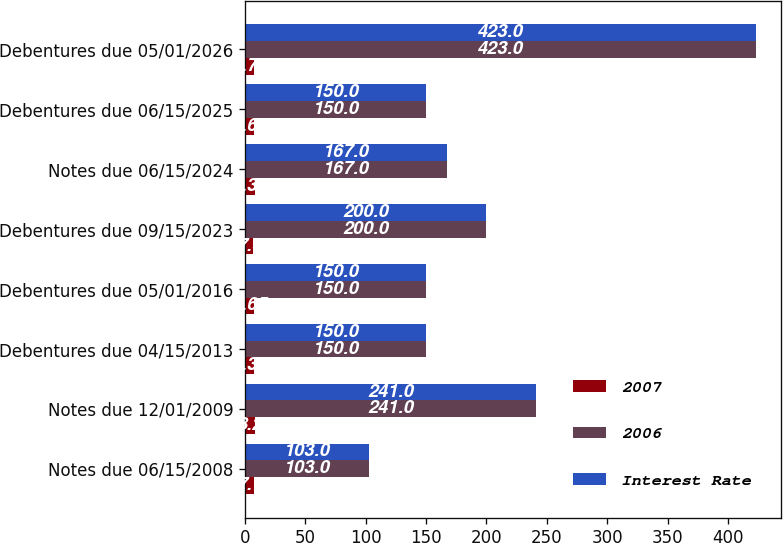Convert chart to OTSL. <chart><loc_0><loc_0><loc_500><loc_500><stacked_bar_chart><ecel><fcel>Notes due 06/15/2008<fcel>Notes due 12/01/2009<fcel>Debentures due 04/15/2013<fcel>Debentures due 05/01/2016<fcel>Debentures due 09/15/2023<fcel>Notes due 06/15/2024<fcel>Debentures due 06/15/2025<fcel>Debentures due 05/01/2026<nl><fcel>2007<fcel>7.7<fcel>8.2<fcel>7.38<fcel>7.65<fcel>7<fcel>8.38<fcel>7.62<fcel>7.75<nl><fcel>2006<fcel>103<fcel>241<fcel>150<fcel>150<fcel>200<fcel>167<fcel>150<fcel>423<nl><fcel>Interest Rate<fcel>103<fcel>241<fcel>150<fcel>150<fcel>200<fcel>167<fcel>150<fcel>423<nl></chart> 